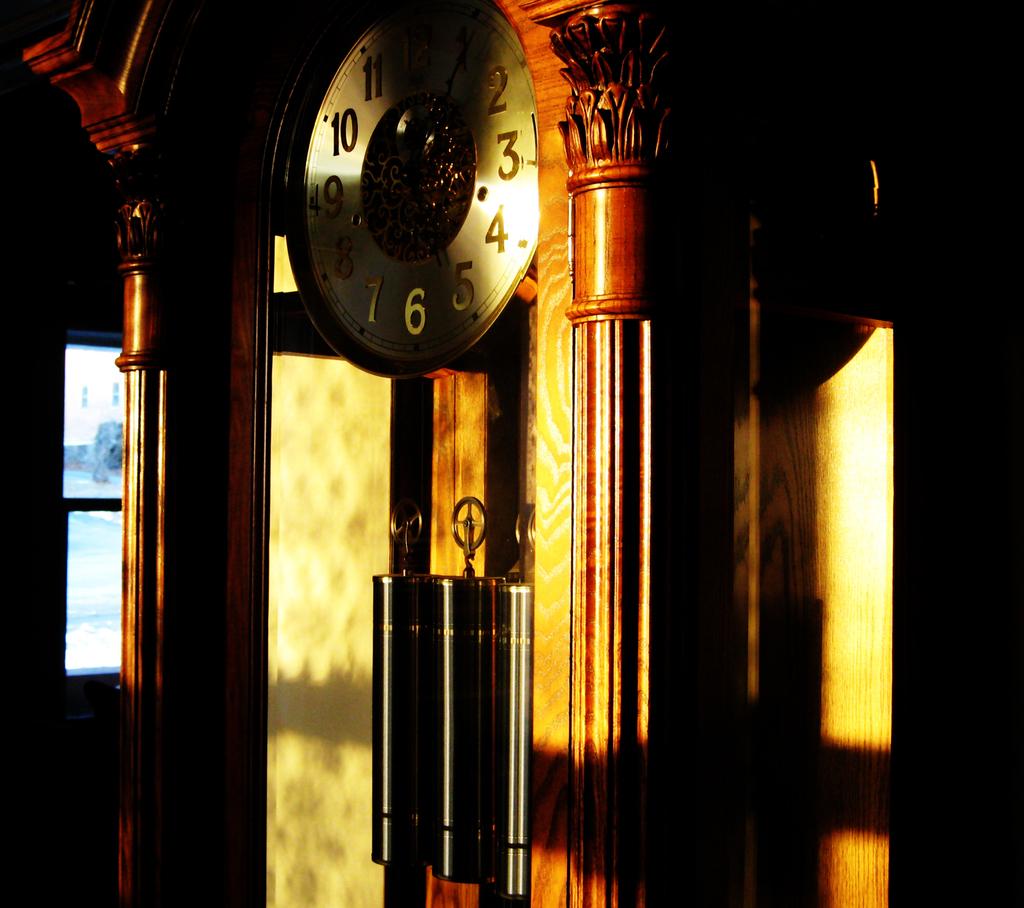Is that a clock?
Keep it short and to the point. Yes. 